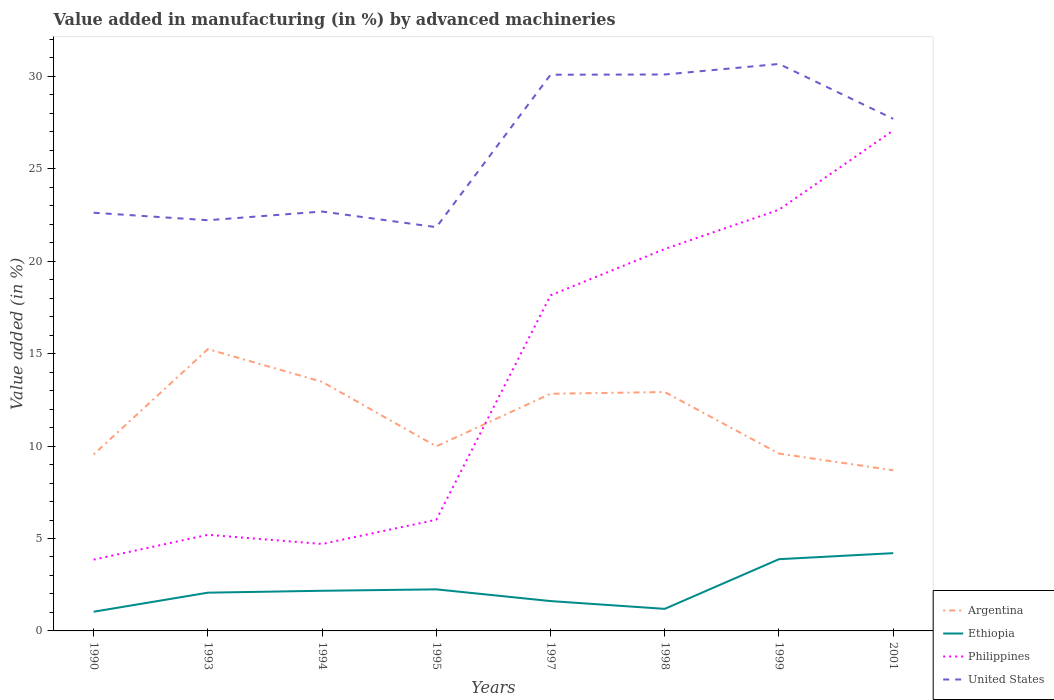How many different coloured lines are there?
Provide a succinct answer. 4. Does the line corresponding to Argentina intersect with the line corresponding to United States?
Provide a short and direct response. No. Across all years, what is the maximum percentage of value added in manufacturing by advanced machineries in Ethiopia?
Keep it short and to the point. 1.04. In which year was the percentage of value added in manufacturing by advanced machineries in Ethiopia maximum?
Make the answer very short. 1990. What is the total percentage of value added in manufacturing by advanced machineries in Argentina in the graph?
Give a very brief answer. 2.42. What is the difference between the highest and the second highest percentage of value added in manufacturing by advanced machineries in Argentina?
Your answer should be very brief. 6.55. How many lines are there?
Your response must be concise. 4. How many years are there in the graph?
Make the answer very short. 8. What is the difference between two consecutive major ticks on the Y-axis?
Your answer should be very brief. 5. Are the values on the major ticks of Y-axis written in scientific E-notation?
Ensure brevity in your answer.  No. Does the graph contain any zero values?
Provide a short and direct response. No. Where does the legend appear in the graph?
Offer a very short reply. Bottom right. How many legend labels are there?
Offer a very short reply. 4. What is the title of the graph?
Provide a short and direct response. Value added in manufacturing (in %) by advanced machineries. What is the label or title of the X-axis?
Offer a terse response. Years. What is the label or title of the Y-axis?
Your answer should be compact. Value added (in %). What is the Value added (in %) in Argentina in 1990?
Offer a terse response. 9.55. What is the Value added (in %) in Ethiopia in 1990?
Offer a terse response. 1.04. What is the Value added (in %) in Philippines in 1990?
Ensure brevity in your answer.  3.86. What is the Value added (in %) of United States in 1990?
Provide a short and direct response. 22.62. What is the Value added (in %) in Argentina in 1993?
Your answer should be compact. 15.25. What is the Value added (in %) of Ethiopia in 1993?
Give a very brief answer. 2.07. What is the Value added (in %) in Philippines in 1993?
Your answer should be very brief. 5.2. What is the Value added (in %) in United States in 1993?
Make the answer very short. 22.22. What is the Value added (in %) of Argentina in 1994?
Keep it short and to the point. 13.47. What is the Value added (in %) of Ethiopia in 1994?
Ensure brevity in your answer.  2.17. What is the Value added (in %) in Philippines in 1994?
Your response must be concise. 4.7. What is the Value added (in %) of United States in 1994?
Keep it short and to the point. 22.69. What is the Value added (in %) of Argentina in 1995?
Make the answer very short. 9.98. What is the Value added (in %) in Ethiopia in 1995?
Make the answer very short. 2.25. What is the Value added (in %) of Philippines in 1995?
Ensure brevity in your answer.  6.01. What is the Value added (in %) of United States in 1995?
Give a very brief answer. 21.84. What is the Value added (in %) of Argentina in 1997?
Offer a very short reply. 12.83. What is the Value added (in %) in Ethiopia in 1997?
Ensure brevity in your answer.  1.61. What is the Value added (in %) of Philippines in 1997?
Offer a very short reply. 18.16. What is the Value added (in %) of United States in 1997?
Make the answer very short. 30.09. What is the Value added (in %) in Argentina in 1998?
Make the answer very short. 12.92. What is the Value added (in %) of Ethiopia in 1998?
Provide a succinct answer. 1.19. What is the Value added (in %) of Philippines in 1998?
Your answer should be compact. 20.66. What is the Value added (in %) of United States in 1998?
Give a very brief answer. 30.1. What is the Value added (in %) in Argentina in 1999?
Keep it short and to the point. 9.59. What is the Value added (in %) in Ethiopia in 1999?
Your response must be concise. 3.88. What is the Value added (in %) in Philippines in 1999?
Provide a short and direct response. 22.79. What is the Value added (in %) of United States in 1999?
Offer a very short reply. 30.67. What is the Value added (in %) in Argentina in 2001?
Make the answer very short. 8.69. What is the Value added (in %) of Ethiopia in 2001?
Offer a very short reply. 4.21. What is the Value added (in %) of Philippines in 2001?
Ensure brevity in your answer.  27.07. What is the Value added (in %) of United States in 2001?
Give a very brief answer. 27.7. Across all years, what is the maximum Value added (in %) in Argentina?
Make the answer very short. 15.25. Across all years, what is the maximum Value added (in %) of Ethiopia?
Your answer should be very brief. 4.21. Across all years, what is the maximum Value added (in %) in Philippines?
Give a very brief answer. 27.07. Across all years, what is the maximum Value added (in %) of United States?
Provide a succinct answer. 30.67. Across all years, what is the minimum Value added (in %) in Argentina?
Ensure brevity in your answer.  8.69. Across all years, what is the minimum Value added (in %) in Ethiopia?
Make the answer very short. 1.04. Across all years, what is the minimum Value added (in %) in Philippines?
Provide a short and direct response. 3.86. Across all years, what is the minimum Value added (in %) of United States?
Offer a very short reply. 21.84. What is the total Value added (in %) of Argentina in the graph?
Provide a succinct answer. 92.29. What is the total Value added (in %) in Ethiopia in the graph?
Offer a terse response. 18.43. What is the total Value added (in %) of Philippines in the graph?
Keep it short and to the point. 108.45. What is the total Value added (in %) of United States in the graph?
Provide a short and direct response. 207.93. What is the difference between the Value added (in %) in Argentina in 1990 and that in 1993?
Provide a short and direct response. -5.7. What is the difference between the Value added (in %) of Ethiopia in 1990 and that in 1993?
Your answer should be compact. -1.03. What is the difference between the Value added (in %) of Philippines in 1990 and that in 1993?
Your answer should be very brief. -1.34. What is the difference between the Value added (in %) in United States in 1990 and that in 1993?
Make the answer very short. 0.4. What is the difference between the Value added (in %) of Argentina in 1990 and that in 1994?
Keep it short and to the point. -3.92. What is the difference between the Value added (in %) of Ethiopia in 1990 and that in 1994?
Provide a short and direct response. -1.13. What is the difference between the Value added (in %) in Philippines in 1990 and that in 1994?
Give a very brief answer. -0.85. What is the difference between the Value added (in %) in United States in 1990 and that in 1994?
Make the answer very short. -0.07. What is the difference between the Value added (in %) in Argentina in 1990 and that in 1995?
Make the answer very short. -0.43. What is the difference between the Value added (in %) in Ethiopia in 1990 and that in 1995?
Provide a succinct answer. -1.21. What is the difference between the Value added (in %) of Philippines in 1990 and that in 1995?
Your response must be concise. -2.16. What is the difference between the Value added (in %) in United States in 1990 and that in 1995?
Provide a short and direct response. 0.78. What is the difference between the Value added (in %) in Argentina in 1990 and that in 1997?
Keep it short and to the point. -3.28. What is the difference between the Value added (in %) of Ethiopia in 1990 and that in 1997?
Offer a terse response. -0.58. What is the difference between the Value added (in %) of Philippines in 1990 and that in 1997?
Keep it short and to the point. -14.3. What is the difference between the Value added (in %) in United States in 1990 and that in 1997?
Your answer should be very brief. -7.47. What is the difference between the Value added (in %) in Argentina in 1990 and that in 1998?
Your answer should be very brief. -3.37. What is the difference between the Value added (in %) in Ethiopia in 1990 and that in 1998?
Offer a terse response. -0.16. What is the difference between the Value added (in %) of Philippines in 1990 and that in 1998?
Your response must be concise. -16.8. What is the difference between the Value added (in %) in United States in 1990 and that in 1998?
Ensure brevity in your answer.  -7.48. What is the difference between the Value added (in %) in Argentina in 1990 and that in 1999?
Give a very brief answer. -0.04. What is the difference between the Value added (in %) in Ethiopia in 1990 and that in 1999?
Ensure brevity in your answer.  -2.84. What is the difference between the Value added (in %) in Philippines in 1990 and that in 1999?
Give a very brief answer. -18.93. What is the difference between the Value added (in %) in United States in 1990 and that in 1999?
Give a very brief answer. -8.05. What is the difference between the Value added (in %) of Argentina in 1990 and that in 2001?
Provide a succinct answer. 0.86. What is the difference between the Value added (in %) of Ethiopia in 1990 and that in 2001?
Give a very brief answer. -3.17. What is the difference between the Value added (in %) of Philippines in 1990 and that in 2001?
Ensure brevity in your answer.  -23.22. What is the difference between the Value added (in %) in United States in 1990 and that in 2001?
Your answer should be compact. -5.08. What is the difference between the Value added (in %) of Argentina in 1993 and that in 1994?
Offer a very short reply. 1.77. What is the difference between the Value added (in %) in Ethiopia in 1993 and that in 1994?
Offer a terse response. -0.1. What is the difference between the Value added (in %) in Philippines in 1993 and that in 1994?
Provide a succinct answer. 0.5. What is the difference between the Value added (in %) in United States in 1993 and that in 1994?
Make the answer very short. -0.47. What is the difference between the Value added (in %) in Argentina in 1993 and that in 1995?
Your answer should be very brief. 5.26. What is the difference between the Value added (in %) of Ethiopia in 1993 and that in 1995?
Offer a very short reply. -0.18. What is the difference between the Value added (in %) of Philippines in 1993 and that in 1995?
Your answer should be compact. -0.82. What is the difference between the Value added (in %) of United States in 1993 and that in 1995?
Offer a terse response. 0.38. What is the difference between the Value added (in %) of Argentina in 1993 and that in 1997?
Your answer should be very brief. 2.42. What is the difference between the Value added (in %) in Ethiopia in 1993 and that in 1997?
Ensure brevity in your answer.  0.46. What is the difference between the Value added (in %) in Philippines in 1993 and that in 1997?
Provide a succinct answer. -12.96. What is the difference between the Value added (in %) in United States in 1993 and that in 1997?
Provide a short and direct response. -7.87. What is the difference between the Value added (in %) of Argentina in 1993 and that in 1998?
Ensure brevity in your answer.  2.32. What is the difference between the Value added (in %) in Ethiopia in 1993 and that in 1998?
Your response must be concise. 0.88. What is the difference between the Value added (in %) in Philippines in 1993 and that in 1998?
Keep it short and to the point. -15.46. What is the difference between the Value added (in %) in United States in 1993 and that in 1998?
Provide a short and direct response. -7.88. What is the difference between the Value added (in %) of Argentina in 1993 and that in 1999?
Offer a very short reply. 5.65. What is the difference between the Value added (in %) of Ethiopia in 1993 and that in 1999?
Offer a terse response. -1.81. What is the difference between the Value added (in %) in Philippines in 1993 and that in 1999?
Provide a short and direct response. -17.59. What is the difference between the Value added (in %) of United States in 1993 and that in 1999?
Your response must be concise. -8.45. What is the difference between the Value added (in %) in Argentina in 1993 and that in 2001?
Make the answer very short. 6.55. What is the difference between the Value added (in %) in Ethiopia in 1993 and that in 2001?
Provide a short and direct response. -2.14. What is the difference between the Value added (in %) of Philippines in 1993 and that in 2001?
Offer a terse response. -21.87. What is the difference between the Value added (in %) in United States in 1993 and that in 2001?
Ensure brevity in your answer.  -5.49. What is the difference between the Value added (in %) in Argentina in 1994 and that in 1995?
Make the answer very short. 3.49. What is the difference between the Value added (in %) of Ethiopia in 1994 and that in 1995?
Give a very brief answer. -0.08. What is the difference between the Value added (in %) in Philippines in 1994 and that in 1995?
Ensure brevity in your answer.  -1.31. What is the difference between the Value added (in %) in United States in 1994 and that in 1995?
Your response must be concise. 0.85. What is the difference between the Value added (in %) of Argentina in 1994 and that in 1997?
Your response must be concise. 0.65. What is the difference between the Value added (in %) in Ethiopia in 1994 and that in 1997?
Offer a very short reply. 0.56. What is the difference between the Value added (in %) of Philippines in 1994 and that in 1997?
Make the answer very short. -13.45. What is the difference between the Value added (in %) in United States in 1994 and that in 1997?
Ensure brevity in your answer.  -7.4. What is the difference between the Value added (in %) in Argentina in 1994 and that in 1998?
Your answer should be compact. 0.55. What is the difference between the Value added (in %) in Philippines in 1994 and that in 1998?
Your answer should be compact. -15.96. What is the difference between the Value added (in %) in United States in 1994 and that in 1998?
Provide a short and direct response. -7.41. What is the difference between the Value added (in %) of Argentina in 1994 and that in 1999?
Make the answer very short. 3.88. What is the difference between the Value added (in %) in Ethiopia in 1994 and that in 1999?
Offer a terse response. -1.71. What is the difference between the Value added (in %) in Philippines in 1994 and that in 1999?
Offer a terse response. -18.08. What is the difference between the Value added (in %) of United States in 1994 and that in 1999?
Provide a succinct answer. -7.98. What is the difference between the Value added (in %) of Argentina in 1994 and that in 2001?
Your answer should be very brief. 4.78. What is the difference between the Value added (in %) in Ethiopia in 1994 and that in 2001?
Your answer should be compact. -2.03. What is the difference between the Value added (in %) of Philippines in 1994 and that in 2001?
Your answer should be compact. -22.37. What is the difference between the Value added (in %) of United States in 1994 and that in 2001?
Keep it short and to the point. -5.02. What is the difference between the Value added (in %) in Argentina in 1995 and that in 1997?
Offer a terse response. -2.84. What is the difference between the Value added (in %) in Ethiopia in 1995 and that in 1997?
Offer a terse response. 0.63. What is the difference between the Value added (in %) in Philippines in 1995 and that in 1997?
Your response must be concise. -12.14. What is the difference between the Value added (in %) of United States in 1995 and that in 1997?
Give a very brief answer. -8.25. What is the difference between the Value added (in %) of Argentina in 1995 and that in 1998?
Your answer should be very brief. -2.94. What is the difference between the Value added (in %) of Ethiopia in 1995 and that in 1998?
Provide a short and direct response. 1.05. What is the difference between the Value added (in %) of Philippines in 1995 and that in 1998?
Give a very brief answer. -14.65. What is the difference between the Value added (in %) of United States in 1995 and that in 1998?
Your response must be concise. -8.26. What is the difference between the Value added (in %) in Argentina in 1995 and that in 1999?
Your response must be concise. 0.39. What is the difference between the Value added (in %) in Ethiopia in 1995 and that in 1999?
Ensure brevity in your answer.  -1.63. What is the difference between the Value added (in %) of Philippines in 1995 and that in 1999?
Ensure brevity in your answer.  -16.77. What is the difference between the Value added (in %) in United States in 1995 and that in 1999?
Your answer should be very brief. -8.83. What is the difference between the Value added (in %) in Argentina in 1995 and that in 2001?
Provide a succinct answer. 1.29. What is the difference between the Value added (in %) in Ethiopia in 1995 and that in 2001?
Your answer should be very brief. -1.96. What is the difference between the Value added (in %) in Philippines in 1995 and that in 2001?
Provide a succinct answer. -21.06. What is the difference between the Value added (in %) in United States in 1995 and that in 2001?
Ensure brevity in your answer.  -5.86. What is the difference between the Value added (in %) of Argentina in 1997 and that in 1998?
Keep it short and to the point. -0.09. What is the difference between the Value added (in %) in Ethiopia in 1997 and that in 1998?
Your answer should be very brief. 0.42. What is the difference between the Value added (in %) of Philippines in 1997 and that in 1998?
Keep it short and to the point. -2.51. What is the difference between the Value added (in %) in United States in 1997 and that in 1998?
Offer a very short reply. -0.01. What is the difference between the Value added (in %) of Argentina in 1997 and that in 1999?
Your answer should be very brief. 3.24. What is the difference between the Value added (in %) of Ethiopia in 1997 and that in 1999?
Offer a very short reply. -2.27. What is the difference between the Value added (in %) of Philippines in 1997 and that in 1999?
Provide a short and direct response. -4.63. What is the difference between the Value added (in %) in United States in 1997 and that in 1999?
Make the answer very short. -0.58. What is the difference between the Value added (in %) in Argentina in 1997 and that in 2001?
Keep it short and to the point. 4.14. What is the difference between the Value added (in %) of Ethiopia in 1997 and that in 2001?
Give a very brief answer. -2.59. What is the difference between the Value added (in %) of Philippines in 1997 and that in 2001?
Give a very brief answer. -8.92. What is the difference between the Value added (in %) in United States in 1997 and that in 2001?
Your answer should be very brief. 2.39. What is the difference between the Value added (in %) of Argentina in 1998 and that in 1999?
Provide a succinct answer. 3.33. What is the difference between the Value added (in %) in Ethiopia in 1998 and that in 1999?
Your response must be concise. -2.69. What is the difference between the Value added (in %) in Philippines in 1998 and that in 1999?
Give a very brief answer. -2.13. What is the difference between the Value added (in %) of United States in 1998 and that in 1999?
Your answer should be very brief. -0.57. What is the difference between the Value added (in %) in Argentina in 1998 and that in 2001?
Your answer should be very brief. 4.23. What is the difference between the Value added (in %) in Ethiopia in 1998 and that in 2001?
Your answer should be very brief. -3.01. What is the difference between the Value added (in %) in Philippines in 1998 and that in 2001?
Your answer should be compact. -6.41. What is the difference between the Value added (in %) in United States in 1998 and that in 2001?
Give a very brief answer. 2.4. What is the difference between the Value added (in %) of Argentina in 1999 and that in 2001?
Provide a succinct answer. 0.9. What is the difference between the Value added (in %) in Ethiopia in 1999 and that in 2001?
Ensure brevity in your answer.  -0.33. What is the difference between the Value added (in %) of Philippines in 1999 and that in 2001?
Make the answer very short. -4.29. What is the difference between the Value added (in %) in United States in 1999 and that in 2001?
Provide a short and direct response. 2.97. What is the difference between the Value added (in %) in Argentina in 1990 and the Value added (in %) in Ethiopia in 1993?
Your response must be concise. 7.48. What is the difference between the Value added (in %) in Argentina in 1990 and the Value added (in %) in Philippines in 1993?
Offer a terse response. 4.35. What is the difference between the Value added (in %) in Argentina in 1990 and the Value added (in %) in United States in 1993?
Ensure brevity in your answer.  -12.67. What is the difference between the Value added (in %) of Ethiopia in 1990 and the Value added (in %) of Philippines in 1993?
Offer a terse response. -4.16. What is the difference between the Value added (in %) of Ethiopia in 1990 and the Value added (in %) of United States in 1993?
Ensure brevity in your answer.  -21.18. What is the difference between the Value added (in %) in Philippines in 1990 and the Value added (in %) in United States in 1993?
Give a very brief answer. -18.36. What is the difference between the Value added (in %) in Argentina in 1990 and the Value added (in %) in Ethiopia in 1994?
Your answer should be very brief. 7.38. What is the difference between the Value added (in %) of Argentina in 1990 and the Value added (in %) of Philippines in 1994?
Ensure brevity in your answer.  4.85. What is the difference between the Value added (in %) in Argentina in 1990 and the Value added (in %) in United States in 1994?
Provide a succinct answer. -13.14. What is the difference between the Value added (in %) in Ethiopia in 1990 and the Value added (in %) in Philippines in 1994?
Your response must be concise. -3.67. What is the difference between the Value added (in %) of Ethiopia in 1990 and the Value added (in %) of United States in 1994?
Offer a very short reply. -21.65. What is the difference between the Value added (in %) of Philippines in 1990 and the Value added (in %) of United States in 1994?
Your answer should be very brief. -18.83. What is the difference between the Value added (in %) in Argentina in 1990 and the Value added (in %) in Ethiopia in 1995?
Offer a very short reply. 7.3. What is the difference between the Value added (in %) of Argentina in 1990 and the Value added (in %) of Philippines in 1995?
Your response must be concise. 3.54. What is the difference between the Value added (in %) of Argentina in 1990 and the Value added (in %) of United States in 1995?
Provide a short and direct response. -12.29. What is the difference between the Value added (in %) of Ethiopia in 1990 and the Value added (in %) of Philippines in 1995?
Make the answer very short. -4.98. What is the difference between the Value added (in %) of Ethiopia in 1990 and the Value added (in %) of United States in 1995?
Make the answer very short. -20.8. What is the difference between the Value added (in %) in Philippines in 1990 and the Value added (in %) in United States in 1995?
Keep it short and to the point. -17.98. What is the difference between the Value added (in %) of Argentina in 1990 and the Value added (in %) of Ethiopia in 1997?
Offer a terse response. 7.94. What is the difference between the Value added (in %) in Argentina in 1990 and the Value added (in %) in Philippines in 1997?
Your response must be concise. -8.61. What is the difference between the Value added (in %) in Argentina in 1990 and the Value added (in %) in United States in 1997?
Provide a short and direct response. -20.54. What is the difference between the Value added (in %) of Ethiopia in 1990 and the Value added (in %) of Philippines in 1997?
Your answer should be very brief. -17.12. What is the difference between the Value added (in %) in Ethiopia in 1990 and the Value added (in %) in United States in 1997?
Your response must be concise. -29.05. What is the difference between the Value added (in %) in Philippines in 1990 and the Value added (in %) in United States in 1997?
Your answer should be very brief. -26.23. What is the difference between the Value added (in %) of Argentina in 1990 and the Value added (in %) of Ethiopia in 1998?
Give a very brief answer. 8.36. What is the difference between the Value added (in %) of Argentina in 1990 and the Value added (in %) of Philippines in 1998?
Offer a terse response. -11.11. What is the difference between the Value added (in %) in Argentina in 1990 and the Value added (in %) in United States in 1998?
Make the answer very short. -20.55. What is the difference between the Value added (in %) of Ethiopia in 1990 and the Value added (in %) of Philippines in 1998?
Your answer should be compact. -19.62. What is the difference between the Value added (in %) of Ethiopia in 1990 and the Value added (in %) of United States in 1998?
Your answer should be compact. -29.06. What is the difference between the Value added (in %) in Philippines in 1990 and the Value added (in %) in United States in 1998?
Offer a very short reply. -26.24. What is the difference between the Value added (in %) in Argentina in 1990 and the Value added (in %) in Ethiopia in 1999?
Your answer should be very brief. 5.67. What is the difference between the Value added (in %) in Argentina in 1990 and the Value added (in %) in Philippines in 1999?
Ensure brevity in your answer.  -13.24. What is the difference between the Value added (in %) in Argentina in 1990 and the Value added (in %) in United States in 1999?
Ensure brevity in your answer.  -21.12. What is the difference between the Value added (in %) of Ethiopia in 1990 and the Value added (in %) of Philippines in 1999?
Provide a short and direct response. -21.75. What is the difference between the Value added (in %) in Ethiopia in 1990 and the Value added (in %) in United States in 1999?
Offer a terse response. -29.63. What is the difference between the Value added (in %) in Philippines in 1990 and the Value added (in %) in United States in 1999?
Offer a very short reply. -26.81. What is the difference between the Value added (in %) in Argentina in 1990 and the Value added (in %) in Ethiopia in 2001?
Ensure brevity in your answer.  5.34. What is the difference between the Value added (in %) in Argentina in 1990 and the Value added (in %) in Philippines in 2001?
Provide a short and direct response. -17.52. What is the difference between the Value added (in %) of Argentina in 1990 and the Value added (in %) of United States in 2001?
Provide a succinct answer. -18.15. What is the difference between the Value added (in %) of Ethiopia in 1990 and the Value added (in %) of Philippines in 2001?
Your answer should be compact. -26.04. What is the difference between the Value added (in %) of Ethiopia in 1990 and the Value added (in %) of United States in 2001?
Your answer should be very brief. -26.66. What is the difference between the Value added (in %) in Philippines in 1990 and the Value added (in %) in United States in 2001?
Offer a terse response. -23.85. What is the difference between the Value added (in %) of Argentina in 1993 and the Value added (in %) of Ethiopia in 1994?
Your answer should be compact. 13.07. What is the difference between the Value added (in %) of Argentina in 1993 and the Value added (in %) of Philippines in 1994?
Your response must be concise. 10.54. What is the difference between the Value added (in %) of Argentina in 1993 and the Value added (in %) of United States in 1994?
Offer a very short reply. -7.44. What is the difference between the Value added (in %) in Ethiopia in 1993 and the Value added (in %) in Philippines in 1994?
Your response must be concise. -2.63. What is the difference between the Value added (in %) of Ethiopia in 1993 and the Value added (in %) of United States in 1994?
Ensure brevity in your answer.  -20.62. What is the difference between the Value added (in %) in Philippines in 1993 and the Value added (in %) in United States in 1994?
Your response must be concise. -17.49. What is the difference between the Value added (in %) in Argentina in 1993 and the Value added (in %) in Ethiopia in 1995?
Your answer should be very brief. 13. What is the difference between the Value added (in %) in Argentina in 1993 and the Value added (in %) in Philippines in 1995?
Give a very brief answer. 9.23. What is the difference between the Value added (in %) in Argentina in 1993 and the Value added (in %) in United States in 1995?
Provide a short and direct response. -6.6. What is the difference between the Value added (in %) of Ethiopia in 1993 and the Value added (in %) of Philippines in 1995?
Keep it short and to the point. -3.95. What is the difference between the Value added (in %) in Ethiopia in 1993 and the Value added (in %) in United States in 1995?
Offer a terse response. -19.77. What is the difference between the Value added (in %) in Philippines in 1993 and the Value added (in %) in United States in 1995?
Your response must be concise. -16.64. What is the difference between the Value added (in %) in Argentina in 1993 and the Value added (in %) in Ethiopia in 1997?
Your response must be concise. 13.63. What is the difference between the Value added (in %) in Argentina in 1993 and the Value added (in %) in Philippines in 1997?
Keep it short and to the point. -2.91. What is the difference between the Value added (in %) in Argentina in 1993 and the Value added (in %) in United States in 1997?
Give a very brief answer. -14.84. What is the difference between the Value added (in %) of Ethiopia in 1993 and the Value added (in %) of Philippines in 1997?
Ensure brevity in your answer.  -16.09. What is the difference between the Value added (in %) of Ethiopia in 1993 and the Value added (in %) of United States in 1997?
Give a very brief answer. -28.02. What is the difference between the Value added (in %) of Philippines in 1993 and the Value added (in %) of United States in 1997?
Provide a succinct answer. -24.89. What is the difference between the Value added (in %) of Argentina in 1993 and the Value added (in %) of Ethiopia in 1998?
Offer a very short reply. 14.05. What is the difference between the Value added (in %) in Argentina in 1993 and the Value added (in %) in Philippines in 1998?
Your response must be concise. -5.42. What is the difference between the Value added (in %) of Argentina in 1993 and the Value added (in %) of United States in 1998?
Your answer should be compact. -14.86. What is the difference between the Value added (in %) of Ethiopia in 1993 and the Value added (in %) of Philippines in 1998?
Offer a terse response. -18.59. What is the difference between the Value added (in %) in Ethiopia in 1993 and the Value added (in %) in United States in 1998?
Your answer should be very brief. -28.03. What is the difference between the Value added (in %) in Philippines in 1993 and the Value added (in %) in United States in 1998?
Your answer should be compact. -24.9. What is the difference between the Value added (in %) of Argentina in 1993 and the Value added (in %) of Ethiopia in 1999?
Ensure brevity in your answer.  11.36. What is the difference between the Value added (in %) in Argentina in 1993 and the Value added (in %) in Philippines in 1999?
Provide a succinct answer. -7.54. What is the difference between the Value added (in %) of Argentina in 1993 and the Value added (in %) of United States in 1999?
Offer a terse response. -15.43. What is the difference between the Value added (in %) in Ethiopia in 1993 and the Value added (in %) in Philippines in 1999?
Keep it short and to the point. -20.72. What is the difference between the Value added (in %) of Ethiopia in 1993 and the Value added (in %) of United States in 1999?
Make the answer very short. -28.6. What is the difference between the Value added (in %) in Philippines in 1993 and the Value added (in %) in United States in 1999?
Your answer should be compact. -25.47. What is the difference between the Value added (in %) in Argentina in 1993 and the Value added (in %) in Ethiopia in 2001?
Make the answer very short. 11.04. What is the difference between the Value added (in %) of Argentina in 1993 and the Value added (in %) of Philippines in 2001?
Provide a succinct answer. -11.83. What is the difference between the Value added (in %) in Argentina in 1993 and the Value added (in %) in United States in 2001?
Offer a very short reply. -12.46. What is the difference between the Value added (in %) of Ethiopia in 1993 and the Value added (in %) of Philippines in 2001?
Provide a succinct answer. -25. What is the difference between the Value added (in %) of Ethiopia in 1993 and the Value added (in %) of United States in 2001?
Offer a terse response. -25.63. What is the difference between the Value added (in %) of Philippines in 1993 and the Value added (in %) of United States in 2001?
Ensure brevity in your answer.  -22.5. What is the difference between the Value added (in %) in Argentina in 1994 and the Value added (in %) in Ethiopia in 1995?
Your response must be concise. 11.23. What is the difference between the Value added (in %) of Argentina in 1994 and the Value added (in %) of Philippines in 1995?
Your answer should be very brief. 7.46. What is the difference between the Value added (in %) in Argentina in 1994 and the Value added (in %) in United States in 1995?
Offer a very short reply. -8.37. What is the difference between the Value added (in %) in Ethiopia in 1994 and the Value added (in %) in Philippines in 1995?
Provide a short and direct response. -3.84. What is the difference between the Value added (in %) of Ethiopia in 1994 and the Value added (in %) of United States in 1995?
Keep it short and to the point. -19.67. What is the difference between the Value added (in %) of Philippines in 1994 and the Value added (in %) of United States in 1995?
Provide a succinct answer. -17.14. What is the difference between the Value added (in %) in Argentina in 1994 and the Value added (in %) in Ethiopia in 1997?
Provide a succinct answer. 11.86. What is the difference between the Value added (in %) of Argentina in 1994 and the Value added (in %) of Philippines in 1997?
Your response must be concise. -4.68. What is the difference between the Value added (in %) in Argentina in 1994 and the Value added (in %) in United States in 1997?
Provide a short and direct response. -16.61. What is the difference between the Value added (in %) in Ethiopia in 1994 and the Value added (in %) in Philippines in 1997?
Provide a short and direct response. -15.98. What is the difference between the Value added (in %) of Ethiopia in 1994 and the Value added (in %) of United States in 1997?
Provide a succinct answer. -27.92. What is the difference between the Value added (in %) of Philippines in 1994 and the Value added (in %) of United States in 1997?
Your answer should be compact. -25.39. What is the difference between the Value added (in %) in Argentina in 1994 and the Value added (in %) in Ethiopia in 1998?
Provide a succinct answer. 12.28. What is the difference between the Value added (in %) in Argentina in 1994 and the Value added (in %) in Philippines in 1998?
Provide a short and direct response. -7.19. What is the difference between the Value added (in %) in Argentina in 1994 and the Value added (in %) in United States in 1998?
Offer a very short reply. -16.63. What is the difference between the Value added (in %) in Ethiopia in 1994 and the Value added (in %) in Philippines in 1998?
Provide a short and direct response. -18.49. What is the difference between the Value added (in %) of Ethiopia in 1994 and the Value added (in %) of United States in 1998?
Your response must be concise. -27.93. What is the difference between the Value added (in %) in Philippines in 1994 and the Value added (in %) in United States in 1998?
Your answer should be very brief. -25.4. What is the difference between the Value added (in %) in Argentina in 1994 and the Value added (in %) in Ethiopia in 1999?
Your answer should be very brief. 9.59. What is the difference between the Value added (in %) in Argentina in 1994 and the Value added (in %) in Philippines in 1999?
Provide a succinct answer. -9.31. What is the difference between the Value added (in %) of Argentina in 1994 and the Value added (in %) of United States in 1999?
Provide a short and direct response. -17.2. What is the difference between the Value added (in %) in Ethiopia in 1994 and the Value added (in %) in Philippines in 1999?
Keep it short and to the point. -20.61. What is the difference between the Value added (in %) of Ethiopia in 1994 and the Value added (in %) of United States in 1999?
Your answer should be compact. -28.5. What is the difference between the Value added (in %) in Philippines in 1994 and the Value added (in %) in United States in 1999?
Your answer should be compact. -25.97. What is the difference between the Value added (in %) of Argentina in 1994 and the Value added (in %) of Ethiopia in 2001?
Keep it short and to the point. 9.27. What is the difference between the Value added (in %) of Argentina in 1994 and the Value added (in %) of Philippines in 2001?
Provide a short and direct response. -13.6. What is the difference between the Value added (in %) in Argentina in 1994 and the Value added (in %) in United States in 2001?
Offer a terse response. -14.23. What is the difference between the Value added (in %) in Ethiopia in 1994 and the Value added (in %) in Philippines in 2001?
Give a very brief answer. -24.9. What is the difference between the Value added (in %) of Ethiopia in 1994 and the Value added (in %) of United States in 2001?
Your response must be concise. -25.53. What is the difference between the Value added (in %) in Philippines in 1994 and the Value added (in %) in United States in 2001?
Make the answer very short. -23. What is the difference between the Value added (in %) in Argentina in 1995 and the Value added (in %) in Ethiopia in 1997?
Offer a very short reply. 8.37. What is the difference between the Value added (in %) in Argentina in 1995 and the Value added (in %) in Philippines in 1997?
Your response must be concise. -8.17. What is the difference between the Value added (in %) of Argentina in 1995 and the Value added (in %) of United States in 1997?
Keep it short and to the point. -20.1. What is the difference between the Value added (in %) in Ethiopia in 1995 and the Value added (in %) in Philippines in 1997?
Keep it short and to the point. -15.91. What is the difference between the Value added (in %) in Ethiopia in 1995 and the Value added (in %) in United States in 1997?
Keep it short and to the point. -27.84. What is the difference between the Value added (in %) of Philippines in 1995 and the Value added (in %) of United States in 1997?
Your answer should be compact. -24.07. What is the difference between the Value added (in %) of Argentina in 1995 and the Value added (in %) of Ethiopia in 1998?
Your answer should be compact. 8.79. What is the difference between the Value added (in %) of Argentina in 1995 and the Value added (in %) of Philippines in 1998?
Offer a very short reply. -10.68. What is the difference between the Value added (in %) of Argentina in 1995 and the Value added (in %) of United States in 1998?
Give a very brief answer. -20.12. What is the difference between the Value added (in %) of Ethiopia in 1995 and the Value added (in %) of Philippines in 1998?
Ensure brevity in your answer.  -18.41. What is the difference between the Value added (in %) of Ethiopia in 1995 and the Value added (in %) of United States in 1998?
Make the answer very short. -27.85. What is the difference between the Value added (in %) in Philippines in 1995 and the Value added (in %) in United States in 1998?
Provide a short and direct response. -24.09. What is the difference between the Value added (in %) of Argentina in 1995 and the Value added (in %) of Ethiopia in 1999?
Keep it short and to the point. 6.1. What is the difference between the Value added (in %) of Argentina in 1995 and the Value added (in %) of Philippines in 1999?
Offer a very short reply. -12.8. What is the difference between the Value added (in %) in Argentina in 1995 and the Value added (in %) in United States in 1999?
Ensure brevity in your answer.  -20.69. What is the difference between the Value added (in %) of Ethiopia in 1995 and the Value added (in %) of Philippines in 1999?
Your response must be concise. -20.54. What is the difference between the Value added (in %) in Ethiopia in 1995 and the Value added (in %) in United States in 1999?
Your answer should be compact. -28.42. What is the difference between the Value added (in %) in Philippines in 1995 and the Value added (in %) in United States in 1999?
Your answer should be very brief. -24.66. What is the difference between the Value added (in %) of Argentina in 1995 and the Value added (in %) of Ethiopia in 2001?
Offer a terse response. 5.78. What is the difference between the Value added (in %) in Argentina in 1995 and the Value added (in %) in Philippines in 2001?
Keep it short and to the point. -17.09. What is the difference between the Value added (in %) of Argentina in 1995 and the Value added (in %) of United States in 2001?
Offer a very short reply. -17.72. What is the difference between the Value added (in %) of Ethiopia in 1995 and the Value added (in %) of Philippines in 2001?
Provide a short and direct response. -24.83. What is the difference between the Value added (in %) in Ethiopia in 1995 and the Value added (in %) in United States in 2001?
Your answer should be compact. -25.45. What is the difference between the Value added (in %) of Philippines in 1995 and the Value added (in %) of United States in 2001?
Make the answer very short. -21.69. What is the difference between the Value added (in %) in Argentina in 1997 and the Value added (in %) in Ethiopia in 1998?
Offer a very short reply. 11.64. What is the difference between the Value added (in %) of Argentina in 1997 and the Value added (in %) of Philippines in 1998?
Offer a very short reply. -7.83. What is the difference between the Value added (in %) of Argentina in 1997 and the Value added (in %) of United States in 1998?
Your answer should be very brief. -17.27. What is the difference between the Value added (in %) of Ethiopia in 1997 and the Value added (in %) of Philippines in 1998?
Your answer should be very brief. -19.05. What is the difference between the Value added (in %) of Ethiopia in 1997 and the Value added (in %) of United States in 1998?
Your answer should be compact. -28.49. What is the difference between the Value added (in %) of Philippines in 1997 and the Value added (in %) of United States in 1998?
Offer a terse response. -11.95. What is the difference between the Value added (in %) in Argentina in 1997 and the Value added (in %) in Ethiopia in 1999?
Make the answer very short. 8.95. What is the difference between the Value added (in %) in Argentina in 1997 and the Value added (in %) in Philippines in 1999?
Give a very brief answer. -9.96. What is the difference between the Value added (in %) in Argentina in 1997 and the Value added (in %) in United States in 1999?
Provide a short and direct response. -17.84. What is the difference between the Value added (in %) in Ethiopia in 1997 and the Value added (in %) in Philippines in 1999?
Make the answer very short. -21.17. What is the difference between the Value added (in %) in Ethiopia in 1997 and the Value added (in %) in United States in 1999?
Your answer should be compact. -29.06. What is the difference between the Value added (in %) in Philippines in 1997 and the Value added (in %) in United States in 1999?
Keep it short and to the point. -12.52. What is the difference between the Value added (in %) in Argentina in 1997 and the Value added (in %) in Ethiopia in 2001?
Give a very brief answer. 8.62. What is the difference between the Value added (in %) in Argentina in 1997 and the Value added (in %) in Philippines in 2001?
Provide a short and direct response. -14.25. What is the difference between the Value added (in %) in Argentina in 1997 and the Value added (in %) in United States in 2001?
Your response must be concise. -14.87. What is the difference between the Value added (in %) of Ethiopia in 1997 and the Value added (in %) of Philippines in 2001?
Offer a terse response. -25.46. What is the difference between the Value added (in %) of Ethiopia in 1997 and the Value added (in %) of United States in 2001?
Offer a terse response. -26.09. What is the difference between the Value added (in %) of Philippines in 1997 and the Value added (in %) of United States in 2001?
Ensure brevity in your answer.  -9.55. What is the difference between the Value added (in %) of Argentina in 1998 and the Value added (in %) of Ethiopia in 1999?
Keep it short and to the point. 9.04. What is the difference between the Value added (in %) in Argentina in 1998 and the Value added (in %) in Philippines in 1999?
Provide a short and direct response. -9.86. What is the difference between the Value added (in %) of Argentina in 1998 and the Value added (in %) of United States in 1999?
Provide a short and direct response. -17.75. What is the difference between the Value added (in %) of Ethiopia in 1998 and the Value added (in %) of Philippines in 1999?
Ensure brevity in your answer.  -21.59. What is the difference between the Value added (in %) of Ethiopia in 1998 and the Value added (in %) of United States in 1999?
Ensure brevity in your answer.  -29.48. What is the difference between the Value added (in %) of Philippines in 1998 and the Value added (in %) of United States in 1999?
Provide a succinct answer. -10.01. What is the difference between the Value added (in %) of Argentina in 1998 and the Value added (in %) of Ethiopia in 2001?
Offer a terse response. 8.72. What is the difference between the Value added (in %) of Argentina in 1998 and the Value added (in %) of Philippines in 2001?
Your answer should be very brief. -14.15. What is the difference between the Value added (in %) in Argentina in 1998 and the Value added (in %) in United States in 2001?
Your answer should be compact. -14.78. What is the difference between the Value added (in %) of Ethiopia in 1998 and the Value added (in %) of Philippines in 2001?
Ensure brevity in your answer.  -25.88. What is the difference between the Value added (in %) of Ethiopia in 1998 and the Value added (in %) of United States in 2001?
Your response must be concise. -26.51. What is the difference between the Value added (in %) of Philippines in 1998 and the Value added (in %) of United States in 2001?
Your answer should be very brief. -7.04. What is the difference between the Value added (in %) of Argentina in 1999 and the Value added (in %) of Ethiopia in 2001?
Make the answer very short. 5.39. What is the difference between the Value added (in %) of Argentina in 1999 and the Value added (in %) of Philippines in 2001?
Your answer should be very brief. -17.48. What is the difference between the Value added (in %) of Argentina in 1999 and the Value added (in %) of United States in 2001?
Make the answer very short. -18.11. What is the difference between the Value added (in %) in Ethiopia in 1999 and the Value added (in %) in Philippines in 2001?
Your response must be concise. -23.19. What is the difference between the Value added (in %) of Ethiopia in 1999 and the Value added (in %) of United States in 2001?
Make the answer very short. -23.82. What is the difference between the Value added (in %) in Philippines in 1999 and the Value added (in %) in United States in 2001?
Provide a short and direct response. -4.92. What is the average Value added (in %) of Argentina per year?
Offer a very short reply. 11.54. What is the average Value added (in %) in Ethiopia per year?
Provide a succinct answer. 2.3. What is the average Value added (in %) of Philippines per year?
Your answer should be very brief. 13.56. What is the average Value added (in %) of United States per year?
Make the answer very short. 25.99. In the year 1990, what is the difference between the Value added (in %) of Argentina and Value added (in %) of Ethiopia?
Make the answer very short. 8.51. In the year 1990, what is the difference between the Value added (in %) of Argentina and Value added (in %) of Philippines?
Make the answer very short. 5.69. In the year 1990, what is the difference between the Value added (in %) in Argentina and Value added (in %) in United States?
Offer a terse response. -13.07. In the year 1990, what is the difference between the Value added (in %) of Ethiopia and Value added (in %) of Philippines?
Keep it short and to the point. -2.82. In the year 1990, what is the difference between the Value added (in %) of Ethiopia and Value added (in %) of United States?
Your answer should be very brief. -21.58. In the year 1990, what is the difference between the Value added (in %) in Philippines and Value added (in %) in United States?
Offer a very short reply. -18.76. In the year 1993, what is the difference between the Value added (in %) in Argentina and Value added (in %) in Ethiopia?
Your answer should be very brief. 13.18. In the year 1993, what is the difference between the Value added (in %) in Argentina and Value added (in %) in Philippines?
Provide a short and direct response. 10.05. In the year 1993, what is the difference between the Value added (in %) in Argentina and Value added (in %) in United States?
Offer a terse response. -6.97. In the year 1993, what is the difference between the Value added (in %) of Ethiopia and Value added (in %) of Philippines?
Keep it short and to the point. -3.13. In the year 1993, what is the difference between the Value added (in %) in Ethiopia and Value added (in %) in United States?
Your answer should be compact. -20.15. In the year 1993, what is the difference between the Value added (in %) in Philippines and Value added (in %) in United States?
Offer a terse response. -17.02. In the year 1994, what is the difference between the Value added (in %) of Argentina and Value added (in %) of Ethiopia?
Keep it short and to the point. 11.3. In the year 1994, what is the difference between the Value added (in %) in Argentina and Value added (in %) in Philippines?
Offer a very short reply. 8.77. In the year 1994, what is the difference between the Value added (in %) in Argentina and Value added (in %) in United States?
Offer a very short reply. -9.21. In the year 1994, what is the difference between the Value added (in %) of Ethiopia and Value added (in %) of Philippines?
Provide a short and direct response. -2.53. In the year 1994, what is the difference between the Value added (in %) of Ethiopia and Value added (in %) of United States?
Your answer should be compact. -20.52. In the year 1994, what is the difference between the Value added (in %) in Philippines and Value added (in %) in United States?
Your answer should be compact. -17.98. In the year 1995, what is the difference between the Value added (in %) in Argentina and Value added (in %) in Ethiopia?
Make the answer very short. 7.74. In the year 1995, what is the difference between the Value added (in %) of Argentina and Value added (in %) of Philippines?
Offer a very short reply. 3.97. In the year 1995, what is the difference between the Value added (in %) in Argentina and Value added (in %) in United States?
Provide a short and direct response. -11.86. In the year 1995, what is the difference between the Value added (in %) of Ethiopia and Value added (in %) of Philippines?
Give a very brief answer. -3.77. In the year 1995, what is the difference between the Value added (in %) in Ethiopia and Value added (in %) in United States?
Make the answer very short. -19.59. In the year 1995, what is the difference between the Value added (in %) of Philippines and Value added (in %) of United States?
Give a very brief answer. -15.83. In the year 1997, what is the difference between the Value added (in %) in Argentina and Value added (in %) in Ethiopia?
Provide a short and direct response. 11.21. In the year 1997, what is the difference between the Value added (in %) of Argentina and Value added (in %) of Philippines?
Provide a short and direct response. -5.33. In the year 1997, what is the difference between the Value added (in %) in Argentina and Value added (in %) in United States?
Provide a short and direct response. -17.26. In the year 1997, what is the difference between the Value added (in %) of Ethiopia and Value added (in %) of Philippines?
Your answer should be very brief. -16.54. In the year 1997, what is the difference between the Value added (in %) in Ethiopia and Value added (in %) in United States?
Make the answer very short. -28.47. In the year 1997, what is the difference between the Value added (in %) of Philippines and Value added (in %) of United States?
Your response must be concise. -11.93. In the year 1998, what is the difference between the Value added (in %) of Argentina and Value added (in %) of Ethiopia?
Ensure brevity in your answer.  11.73. In the year 1998, what is the difference between the Value added (in %) of Argentina and Value added (in %) of Philippines?
Offer a terse response. -7.74. In the year 1998, what is the difference between the Value added (in %) in Argentina and Value added (in %) in United States?
Your answer should be compact. -17.18. In the year 1998, what is the difference between the Value added (in %) in Ethiopia and Value added (in %) in Philippines?
Your response must be concise. -19.47. In the year 1998, what is the difference between the Value added (in %) of Ethiopia and Value added (in %) of United States?
Your response must be concise. -28.91. In the year 1998, what is the difference between the Value added (in %) of Philippines and Value added (in %) of United States?
Provide a succinct answer. -9.44. In the year 1999, what is the difference between the Value added (in %) in Argentina and Value added (in %) in Ethiopia?
Ensure brevity in your answer.  5.71. In the year 1999, what is the difference between the Value added (in %) in Argentina and Value added (in %) in Philippines?
Give a very brief answer. -13.19. In the year 1999, what is the difference between the Value added (in %) in Argentina and Value added (in %) in United States?
Give a very brief answer. -21.08. In the year 1999, what is the difference between the Value added (in %) in Ethiopia and Value added (in %) in Philippines?
Your answer should be compact. -18.91. In the year 1999, what is the difference between the Value added (in %) of Ethiopia and Value added (in %) of United States?
Provide a succinct answer. -26.79. In the year 1999, what is the difference between the Value added (in %) of Philippines and Value added (in %) of United States?
Provide a succinct answer. -7.88. In the year 2001, what is the difference between the Value added (in %) of Argentina and Value added (in %) of Ethiopia?
Give a very brief answer. 4.48. In the year 2001, what is the difference between the Value added (in %) of Argentina and Value added (in %) of Philippines?
Ensure brevity in your answer.  -18.38. In the year 2001, what is the difference between the Value added (in %) in Argentina and Value added (in %) in United States?
Your answer should be compact. -19.01. In the year 2001, what is the difference between the Value added (in %) of Ethiopia and Value added (in %) of Philippines?
Ensure brevity in your answer.  -22.87. In the year 2001, what is the difference between the Value added (in %) in Ethiopia and Value added (in %) in United States?
Your answer should be very brief. -23.5. In the year 2001, what is the difference between the Value added (in %) in Philippines and Value added (in %) in United States?
Offer a very short reply. -0.63. What is the ratio of the Value added (in %) in Argentina in 1990 to that in 1993?
Make the answer very short. 0.63. What is the ratio of the Value added (in %) in Ethiopia in 1990 to that in 1993?
Keep it short and to the point. 0.5. What is the ratio of the Value added (in %) of Philippines in 1990 to that in 1993?
Provide a short and direct response. 0.74. What is the ratio of the Value added (in %) of United States in 1990 to that in 1993?
Give a very brief answer. 1.02. What is the ratio of the Value added (in %) of Argentina in 1990 to that in 1994?
Your answer should be very brief. 0.71. What is the ratio of the Value added (in %) of Ethiopia in 1990 to that in 1994?
Provide a succinct answer. 0.48. What is the ratio of the Value added (in %) of Philippines in 1990 to that in 1994?
Your answer should be compact. 0.82. What is the ratio of the Value added (in %) of Argentina in 1990 to that in 1995?
Provide a short and direct response. 0.96. What is the ratio of the Value added (in %) in Ethiopia in 1990 to that in 1995?
Offer a very short reply. 0.46. What is the ratio of the Value added (in %) of Philippines in 1990 to that in 1995?
Give a very brief answer. 0.64. What is the ratio of the Value added (in %) of United States in 1990 to that in 1995?
Provide a succinct answer. 1.04. What is the ratio of the Value added (in %) of Argentina in 1990 to that in 1997?
Your answer should be very brief. 0.74. What is the ratio of the Value added (in %) of Ethiopia in 1990 to that in 1997?
Your response must be concise. 0.64. What is the ratio of the Value added (in %) of Philippines in 1990 to that in 1997?
Your response must be concise. 0.21. What is the ratio of the Value added (in %) in United States in 1990 to that in 1997?
Provide a succinct answer. 0.75. What is the ratio of the Value added (in %) of Argentina in 1990 to that in 1998?
Your answer should be very brief. 0.74. What is the ratio of the Value added (in %) in Ethiopia in 1990 to that in 1998?
Offer a very short reply. 0.87. What is the ratio of the Value added (in %) in Philippines in 1990 to that in 1998?
Your answer should be very brief. 0.19. What is the ratio of the Value added (in %) in United States in 1990 to that in 1998?
Keep it short and to the point. 0.75. What is the ratio of the Value added (in %) of Ethiopia in 1990 to that in 1999?
Make the answer very short. 0.27. What is the ratio of the Value added (in %) of Philippines in 1990 to that in 1999?
Offer a very short reply. 0.17. What is the ratio of the Value added (in %) in United States in 1990 to that in 1999?
Offer a very short reply. 0.74. What is the ratio of the Value added (in %) in Argentina in 1990 to that in 2001?
Provide a short and direct response. 1.1. What is the ratio of the Value added (in %) in Ethiopia in 1990 to that in 2001?
Provide a short and direct response. 0.25. What is the ratio of the Value added (in %) in Philippines in 1990 to that in 2001?
Offer a terse response. 0.14. What is the ratio of the Value added (in %) of United States in 1990 to that in 2001?
Your answer should be very brief. 0.82. What is the ratio of the Value added (in %) of Argentina in 1993 to that in 1994?
Ensure brevity in your answer.  1.13. What is the ratio of the Value added (in %) of Ethiopia in 1993 to that in 1994?
Ensure brevity in your answer.  0.95. What is the ratio of the Value added (in %) in Philippines in 1993 to that in 1994?
Keep it short and to the point. 1.11. What is the ratio of the Value added (in %) of United States in 1993 to that in 1994?
Ensure brevity in your answer.  0.98. What is the ratio of the Value added (in %) of Argentina in 1993 to that in 1995?
Ensure brevity in your answer.  1.53. What is the ratio of the Value added (in %) of Ethiopia in 1993 to that in 1995?
Your response must be concise. 0.92. What is the ratio of the Value added (in %) of Philippines in 1993 to that in 1995?
Give a very brief answer. 0.86. What is the ratio of the Value added (in %) of United States in 1993 to that in 1995?
Offer a terse response. 1.02. What is the ratio of the Value added (in %) in Argentina in 1993 to that in 1997?
Keep it short and to the point. 1.19. What is the ratio of the Value added (in %) of Ethiopia in 1993 to that in 1997?
Offer a very short reply. 1.28. What is the ratio of the Value added (in %) of Philippines in 1993 to that in 1997?
Provide a succinct answer. 0.29. What is the ratio of the Value added (in %) in United States in 1993 to that in 1997?
Provide a succinct answer. 0.74. What is the ratio of the Value added (in %) in Argentina in 1993 to that in 1998?
Provide a succinct answer. 1.18. What is the ratio of the Value added (in %) of Ethiopia in 1993 to that in 1998?
Your response must be concise. 1.73. What is the ratio of the Value added (in %) of Philippines in 1993 to that in 1998?
Make the answer very short. 0.25. What is the ratio of the Value added (in %) in United States in 1993 to that in 1998?
Make the answer very short. 0.74. What is the ratio of the Value added (in %) of Argentina in 1993 to that in 1999?
Provide a succinct answer. 1.59. What is the ratio of the Value added (in %) of Ethiopia in 1993 to that in 1999?
Provide a succinct answer. 0.53. What is the ratio of the Value added (in %) in Philippines in 1993 to that in 1999?
Give a very brief answer. 0.23. What is the ratio of the Value added (in %) of United States in 1993 to that in 1999?
Keep it short and to the point. 0.72. What is the ratio of the Value added (in %) of Argentina in 1993 to that in 2001?
Make the answer very short. 1.75. What is the ratio of the Value added (in %) of Ethiopia in 1993 to that in 2001?
Make the answer very short. 0.49. What is the ratio of the Value added (in %) of Philippines in 1993 to that in 2001?
Provide a succinct answer. 0.19. What is the ratio of the Value added (in %) in United States in 1993 to that in 2001?
Keep it short and to the point. 0.8. What is the ratio of the Value added (in %) of Argentina in 1994 to that in 1995?
Your answer should be compact. 1.35. What is the ratio of the Value added (in %) of Ethiopia in 1994 to that in 1995?
Keep it short and to the point. 0.97. What is the ratio of the Value added (in %) of Philippines in 1994 to that in 1995?
Your answer should be compact. 0.78. What is the ratio of the Value added (in %) in United States in 1994 to that in 1995?
Make the answer very short. 1.04. What is the ratio of the Value added (in %) of Argentina in 1994 to that in 1997?
Your response must be concise. 1.05. What is the ratio of the Value added (in %) of Ethiopia in 1994 to that in 1997?
Give a very brief answer. 1.35. What is the ratio of the Value added (in %) of Philippines in 1994 to that in 1997?
Offer a very short reply. 0.26. What is the ratio of the Value added (in %) of United States in 1994 to that in 1997?
Make the answer very short. 0.75. What is the ratio of the Value added (in %) in Argentina in 1994 to that in 1998?
Give a very brief answer. 1.04. What is the ratio of the Value added (in %) in Ethiopia in 1994 to that in 1998?
Offer a very short reply. 1.82. What is the ratio of the Value added (in %) of Philippines in 1994 to that in 1998?
Your answer should be very brief. 0.23. What is the ratio of the Value added (in %) in United States in 1994 to that in 1998?
Keep it short and to the point. 0.75. What is the ratio of the Value added (in %) in Argentina in 1994 to that in 1999?
Your answer should be compact. 1.4. What is the ratio of the Value added (in %) in Ethiopia in 1994 to that in 1999?
Your response must be concise. 0.56. What is the ratio of the Value added (in %) in Philippines in 1994 to that in 1999?
Offer a terse response. 0.21. What is the ratio of the Value added (in %) of United States in 1994 to that in 1999?
Offer a very short reply. 0.74. What is the ratio of the Value added (in %) in Argentina in 1994 to that in 2001?
Your response must be concise. 1.55. What is the ratio of the Value added (in %) in Ethiopia in 1994 to that in 2001?
Provide a short and direct response. 0.52. What is the ratio of the Value added (in %) of Philippines in 1994 to that in 2001?
Make the answer very short. 0.17. What is the ratio of the Value added (in %) of United States in 1994 to that in 2001?
Provide a succinct answer. 0.82. What is the ratio of the Value added (in %) in Argentina in 1995 to that in 1997?
Your response must be concise. 0.78. What is the ratio of the Value added (in %) of Ethiopia in 1995 to that in 1997?
Keep it short and to the point. 1.39. What is the ratio of the Value added (in %) in Philippines in 1995 to that in 1997?
Your answer should be compact. 0.33. What is the ratio of the Value added (in %) in United States in 1995 to that in 1997?
Your answer should be very brief. 0.73. What is the ratio of the Value added (in %) in Argentina in 1995 to that in 1998?
Keep it short and to the point. 0.77. What is the ratio of the Value added (in %) in Ethiopia in 1995 to that in 1998?
Offer a very short reply. 1.88. What is the ratio of the Value added (in %) of Philippines in 1995 to that in 1998?
Your answer should be compact. 0.29. What is the ratio of the Value added (in %) in United States in 1995 to that in 1998?
Make the answer very short. 0.73. What is the ratio of the Value added (in %) in Argentina in 1995 to that in 1999?
Provide a succinct answer. 1.04. What is the ratio of the Value added (in %) in Ethiopia in 1995 to that in 1999?
Provide a short and direct response. 0.58. What is the ratio of the Value added (in %) of Philippines in 1995 to that in 1999?
Give a very brief answer. 0.26. What is the ratio of the Value added (in %) in United States in 1995 to that in 1999?
Offer a terse response. 0.71. What is the ratio of the Value added (in %) of Argentina in 1995 to that in 2001?
Offer a terse response. 1.15. What is the ratio of the Value added (in %) of Ethiopia in 1995 to that in 2001?
Offer a very short reply. 0.53. What is the ratio of the Value added (in %) of Philippines in 1995 to that in 2001?
Offer a terse response. 0.22. What is the ratio of the Value added (in %) in United States in 1995 to that in 2001?
Provide a short and direct response. 0.79. What is the ratio of the Value added (in %) of Ethiopia in 1997 to that in 1998?
Provide a short and direct response. 1.35. What is the ratio of the Value added (in %) in Philippines in 1997 to that in 1998?
Give a very brief answer. 0.88. What is the ratio of the Value added (in %) of United States in 1997 to that in 1998?
Make the answer very short. 1. What is the ratio of the Value added (in %) of Argentina in 1997 to that in 1999?
Your response must be concise. 1.34. What is the ratio of the Value added (in %) of Ethiopia in 1997 to that in 1999?
Your answer should be compact. 0.42. What is the ratio of the Value added (in %) in Philippines in 1997 to that in 1999?
Keep it short and to the point. 0.8. What is the ratio of the Value added (in %) in Argentina in 1997 to that in 2001?
Your response must be concise. 1.48. What is the ratio of the Value added (in %) of Ethiopia in 1997 to that in 2001?
Your answer should be compact. 0.38. What is the ratio of the Value added (in %) of Philippines in 1997 to that in 2001?
Your response must be concise. 0.67. What is the ratio of the Value added (in %) in United States in 1997 to that in 2001?
Keep it short and to the point. 1.09. What is the ratio of the Value added (in %) of Argentina in 1998 to that in 1999?
Give a very brief answer. 1.35. What is the ratio of the Value added (in %) of Ethiopia in 1998 to that in 1999?
Keep it short and to the point. 0.31. What is the ratio of the Value added (in %) of Philippines in 1998 to that in 1999?
Your answer should be compact. 0.91. What is the ratio of the Value added (in %) of United States in 1998 to that in 1999?
Ensure brevity in your answer.  0.98. What is the ratio of the Value added (in %) in Argentina in 1998 to that in 2001?
Offer a very short reply. 1.49. What is the ratio of the Value added (in %) in Ethiopia in 1998 to that in 2001?
Ensure brevity in your answer.  0.28. What is the ratio of the Value added (in %) in Philippines in 1998 to that in 2001?
Offer a terse response. 0.76. What is the ratio of the Value added (in %) of United States in 1998 to that in 2001?
Offer a very short reply. 1.09. What is the ratio of the Value added (in %) in Argentina in 1999 to that in 2001?
Your answer should be very brief. 1.1. What is the ratio of the Value added (in %) of Ethiopia in 1999 to that in 2001?
Provide a succinct answer. 0.92. What is the ratio of the Value added (in %) in Philippines in 1999 to that in 2001?
Keep it short and to the point. 0.84. What is the ratio of the Value added (in %) in United States in 1999 to that in 2001?
Offer a very short reply. 1.11. What is the difference between the highest and the second highest Value added (in %) in Argentina?
Keep it short and to the point. 1.77. What is the difference between the highest and the second highest Value added (in %) in Ethiopia?
Offer a very short reply. 0.33. What is the difference between the highest and the second highest Value added (in %) in Philippines?
Make the answer very short. 4.29. What is the difference between the highest and the second highest Value added (in %) in United States?
Your answer should be compact. 0.57. What is the difference between the highest and the lowest Value added (in %) of Argentina?
Provide a succinct answer. 6.55. What is the difference between the highest and the lowest Value added (in %) in Ethiopia?
Ensure brevity in your answer.  3.17. What is the difference between the highest and the lowest Value added (in %) of Philippines?
Keep it short and to the point. 23.22. What is the difference between the highest and the lowest Value added (in %) in United States?
Provide a succinct answer. 8.83. 